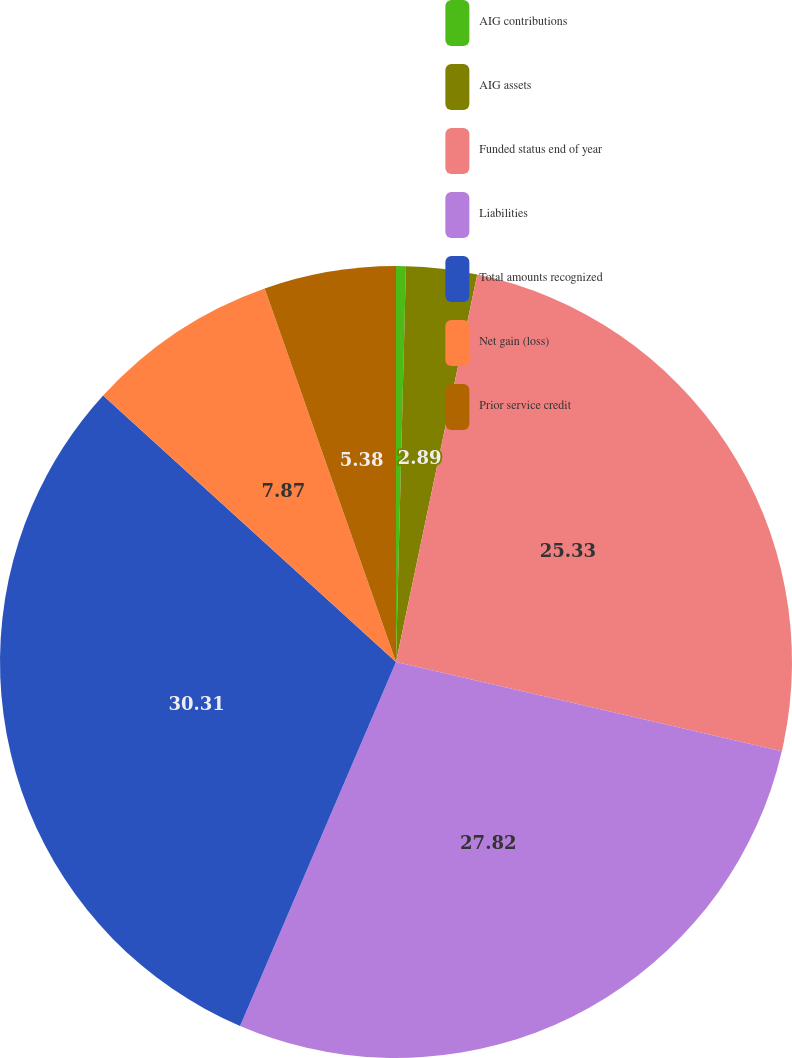Convert chart. <chart><loc_0><loc_0><loc_500><loc_500><pie_chart><fcel>AIG contributions<fcel>AIG assets<fcel>Funded status end of year<fcel>Liabilities<fcel>Total amounts recognized<fcel>Net gain (loss)<fcel>Prior service credit<nl><fcel>0.4%<fcel>2.89%<fcel>25.33%<fcel>27.82%<fcel>30.31%<fcel>7.87%<fcel>5.38%<nl></chart> 